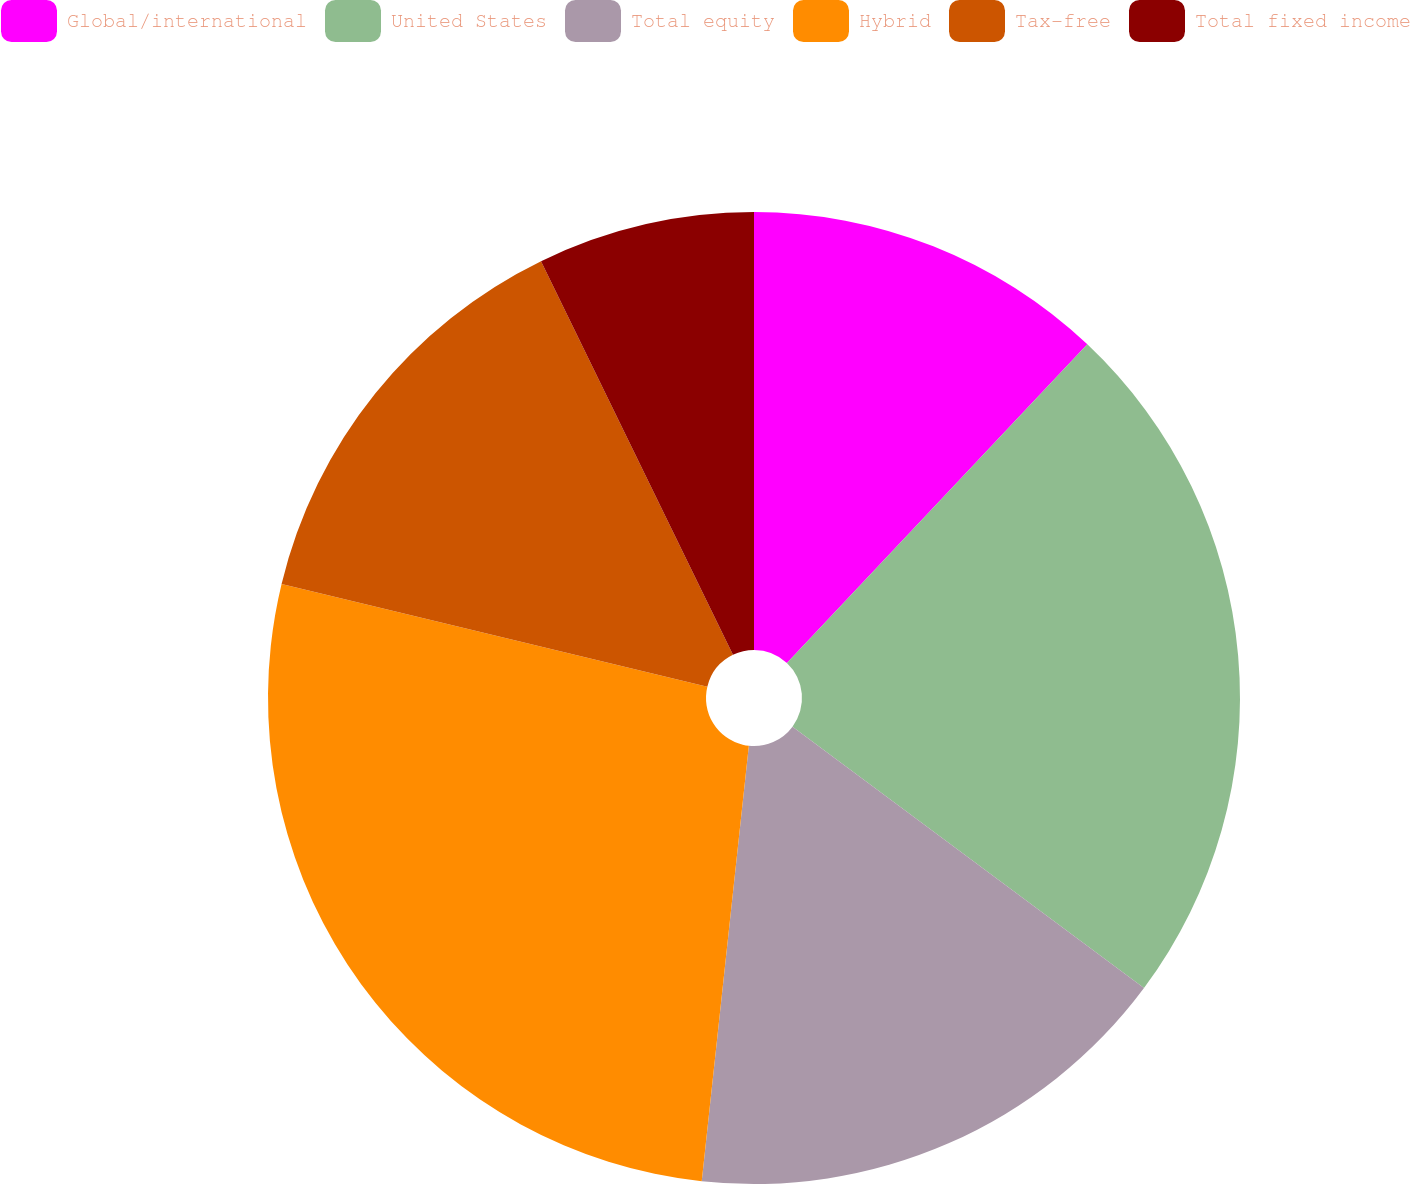Convert chart to OTSL. <chart><loc_0><loc_0><loc_500><loc_500><pie_chart><fcel>Global/international<fcel>United States<fcel>Total equity<fcel>Hybrid<fcel>Tax-free<fcel>Total fixed income<nl><fcel>12.03%<fcel>23.15%<fcel>16.54%<fcel>27.06%<fcel>14.01%<fcel>7.22%<nl></chart> 